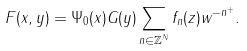Convert formula to latex. <formula><loc_0><loc_0><loc_500><loc_500>F ( x , y ) = \Psi _ { 0 } ( x ) G ( y ) \sum _ { n \in \mathbb { Z } ^ { N } } f _ { n } ( z ) w ^ { - n ^ { + } } .</formula> 